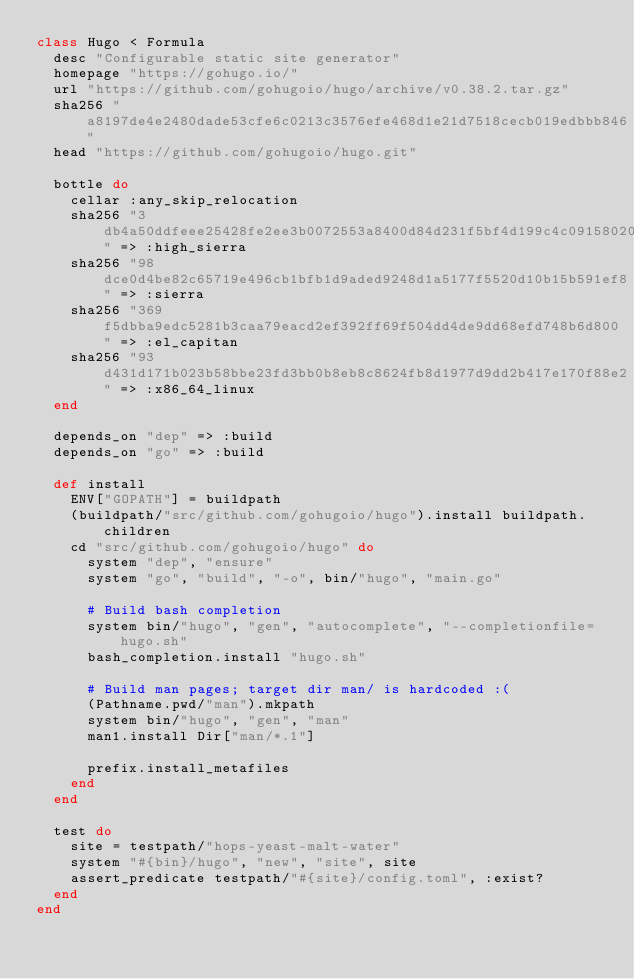<code> <loc_0><loc_0><loc_500><loc_500><_Ruby_>class Hugo < Formula
  desc "Configurable static site generator"
  homepage "https://gohugo.io/"
  url "https://github.com/gohugoio/hugo/archive/v0.38.2.tar.gz"
  sha256 "a8197de4e2480dade53cfe6c0213c3576efe468d1e21d7518cecb019edbbb846"
  head "https://github.com/gohugoio/hugo.git"

  bottle do
    cellar :any_skip_relocation
    sha256 "3db4a50ddfeee25428fe2ee3b0072553a8400d84d231f5bf4d199c4c09158020" => :high_sierra
    sha256 "98dce0d4be82c65719e496cb1bfb1d9aded9248d1a5177f5520d10b15b591ef8" => :sierra
    sha256 "369f5dbba9edc5281b3caa79eacd2ef392ff69f504dd4de9dd68efd748b6d800" => :el_capitan
    sha256 "93d431d171b023b58bbe23fd3bb0b8eb8c8624fb8d1977d9dd2b417e170f88e2" => :x86_64_linux
  end

  depends_on "dep" => :build
  depends_on "go" => :build

  def install
    ENV["GOPATH"] = buildpath
    (buildpath/"src/github.com/gohugoio/hugo").install buildpath.children
    cd "src/github.com/gohugoio/hugo" do
      system "dep", "ensure"
      system "go", "build", "-o", bin/"hugo", "main.go"

      # Build bash completion
      system bin/"hugo", "gen", "autocomplete", "--completionfile=hugo.sh"
      bash_completion.install "hugo.sh"

      # Build man pages; target dir man/ is hardcoded :(
      (Pathname.pwd/"man").mkpath
      system bin/"hugo", "gen", "man"
      man1.install Dir["man/*.1"]

      prefix.install_metafiles
    end
  end

  test do
    site = testpath/"hops-yeast-malt-water"
    system "#{bin}/hugo", "new", "site", site
    assert_predicate testpath/"#{site}/config.toml", :exist?
  end
end
</code> 